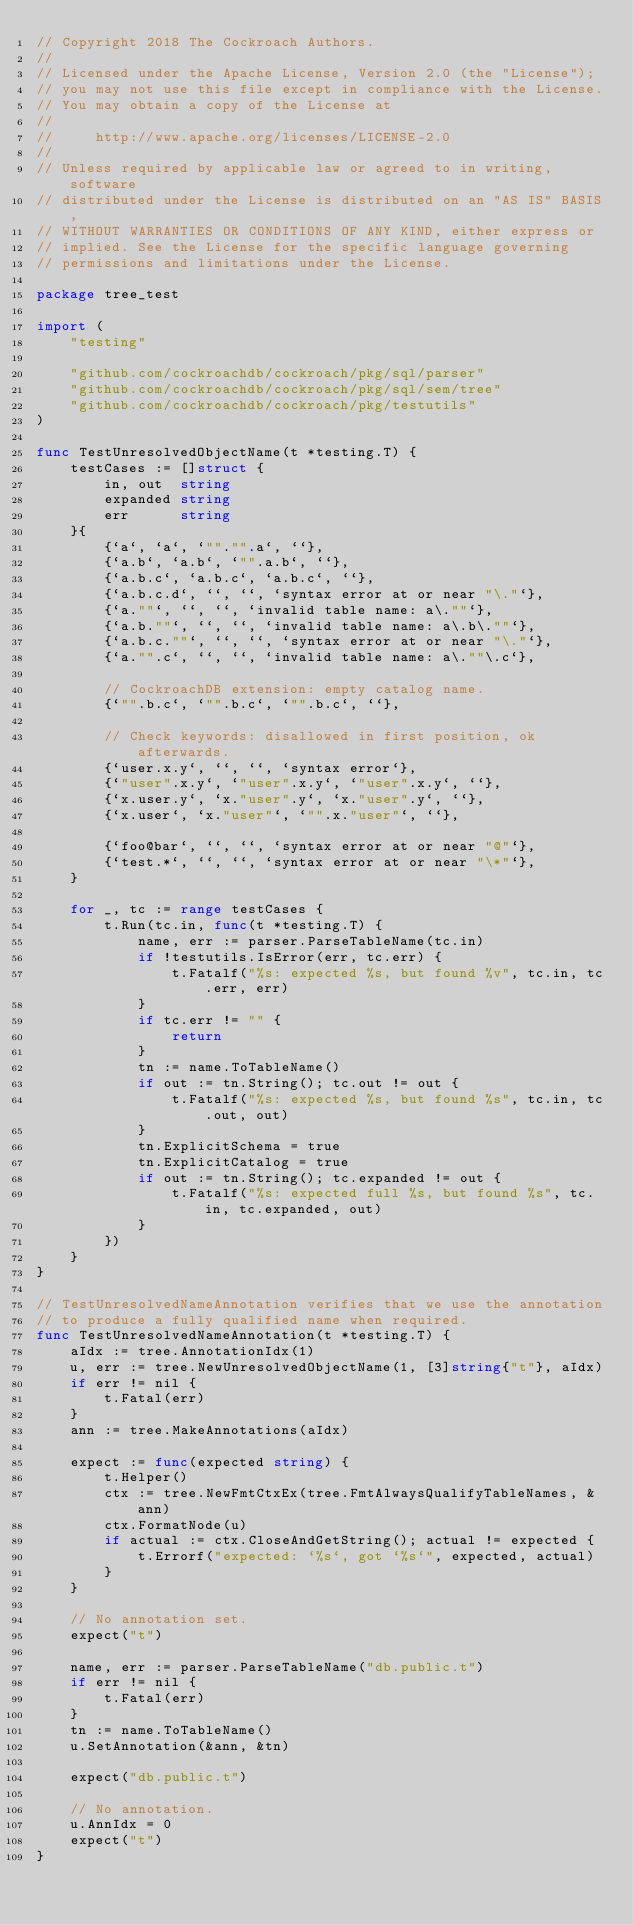<code> <loc_0><loc_0><loc_500><loc_500><_Go_>// Copyright 2018 The Cockroach Authors.
//
// Licensed under the Apache License, Version 2.0 (the "License");
// you may not use this file except in compliance with the License.
// You may obtain a copy of the License at
//
//     http://www.apache.org/licenses/LICENSE-2.0
//
// Unless required by applicable law or agreed to in writing, software
// distributed under the License is distributed on an "AS IS" BASIS,
// WITHOUT WARRANTIES OR CONDITIONS OF ANY KIND, either express or
// implied. See the License for the specific language governing
// permissions and limitations under the License.

package tree_test

import (
	"testing"

	"github.com/cockroachdb/cockroach/pkg/sql/parser"
	"github.com/cockroachdb/cockroach/pkg/sql/sem/tree"
	"github.com/cockroachdb/cockroach/pkg/testutils"
)

func TestUnresolvedObjectName(t *testing.T) {
	testCases := []struct {
		in, out  string
		expanded string
		err      string
	}{
		{`a`, `a`, `""."".a`, ``},
		{`a.b`, `a.b`, `"".a.b`, ``},
		{`a.b.c`, `a.b.c`, `a.b.c`, ``},
		{`a.b.c.d`, ``, ``, `syntax error at or near "\."`},
		{`a.""`, ``, ``, `invalid table name: a\.""`},
		{`a.b.""`, ``, ``, `invalid table name: a\.b\.""`},
		{`a.b.c.""`, ``, ``, `syntax error at or near "\."`},
		{`a."".c`, ``, ``, `invalid table name: a\.""\.c`},

		// CockroachDB extension: empty catalog name.
		{`"".b.c`, `"".b.c`, `"".b.c`, ``},

		// Check keywords: disallowed in first position, ok afterwards.
		{`user.x.y`, ``, ``, `syntax error`},
		{`"user".x.y`, `"user".x.y`, `"user".x.y`, ``},
		{`x.user.y`, `x."user".y`, `x."user".y`, ``},
		{`x.user`, `x."user"`, `"".x."user"`, ``},

		{`foo@bar`, ``, ``, `syntax error at or near "@"`},
		{`test.*`, ``, ``, `syntax error at or near "\*"`},
	}

	for _, tc := range testCases {
		t.Run(tc.in, func(t *testing.T) {
			name, err := parser.ParseTableName(tc.in)
			if !testutils.IsError(err, tc.err) {
				t.Fatalf("%s: expected %s, but found %v", tc.in, tc.err, err)
			}
			if tc.err != "" {
				return
			}
			tn := name.ToTableName()
			if out := tn.String(); tc.out != out {
				t.Fatalf("%s: expected %s, but found %s", tc.in, tc.out, out)
			}
			tn.ExplicitSchema = true
			tn.ExplicitCatalog = true
			if out := tn.String(); tc.expanded != out {
				t.Fatalf("%s: expected full %s, but found %s", tc.in, tc.expanded, out)
			}
		})
	}
}

// TestUnresolvedNameAnnotation verifies that we use the annotation
// to produce a fully qualified name when required.
func TestUnresolvedNameAnnotation(t *testing.T) {
	aIdx := tree.AnnotationIdx(1)
	u, err := tree.NewUnresolvedObjectName(1, [3]string{"t"}, aIdx)
	if err != nil {
		t.Fatal(err)
	}
	ann := tree.MakeAnnotations(aIdx)

	expect := func(expected string) {
		t.Helper()
		ctx := tree.NewFmtCtxEx(tree.FmtAlwaysQualifyTableNames, &ann)
		ctx.FormatNode(u)
		if actual := ctx.CloseAndGetString(); actual != expected {
			t.Errorf("expected: `%s`, got `%s`", expected, actual)
		}
	}

	// No annotation set.
	expect("t")

	name, err := parser.ParseTableName("db.public.t")
	if err != nil {
		t.Fatal(err)
	}
	tn := name.ToTableName()
	u.SetAnnotation(&ann, &tn)

	expect("db.public.t")

	// No annotation.
	u.AnnIdx = 0
	expect("t")
}
</code> 